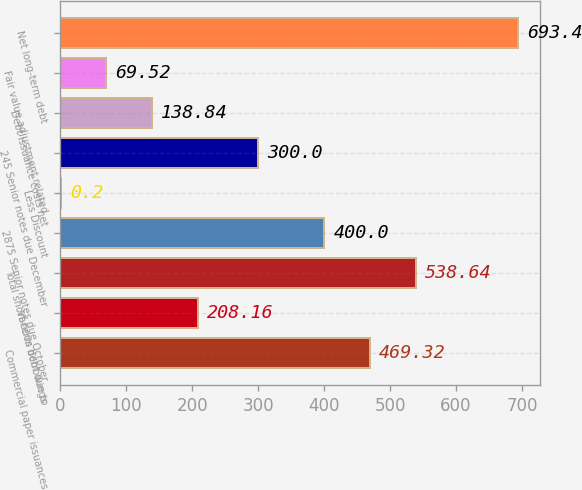Convert chart. <chart><loc_0><loc_0><loc_500><loc_500><bar_chart><fcel>Commercial paper issuances<fcel>Various debt due to<fcel>Total short-term borrowings<fcel>2875 Senior notes due October<fcel>Less Discount<fcel>245 Senior notes due December<fcel>Debt issuance costs net<fcel>Fair value adjustment related<fcel>Net long-term debt<nl><fcel>469.32<fcel>208.16<fcel>538.64<fcel>400<fcel>0.2<fcel>300<fcel>138.84<fcel>69.52<fcel>693.4<nl></chart> 